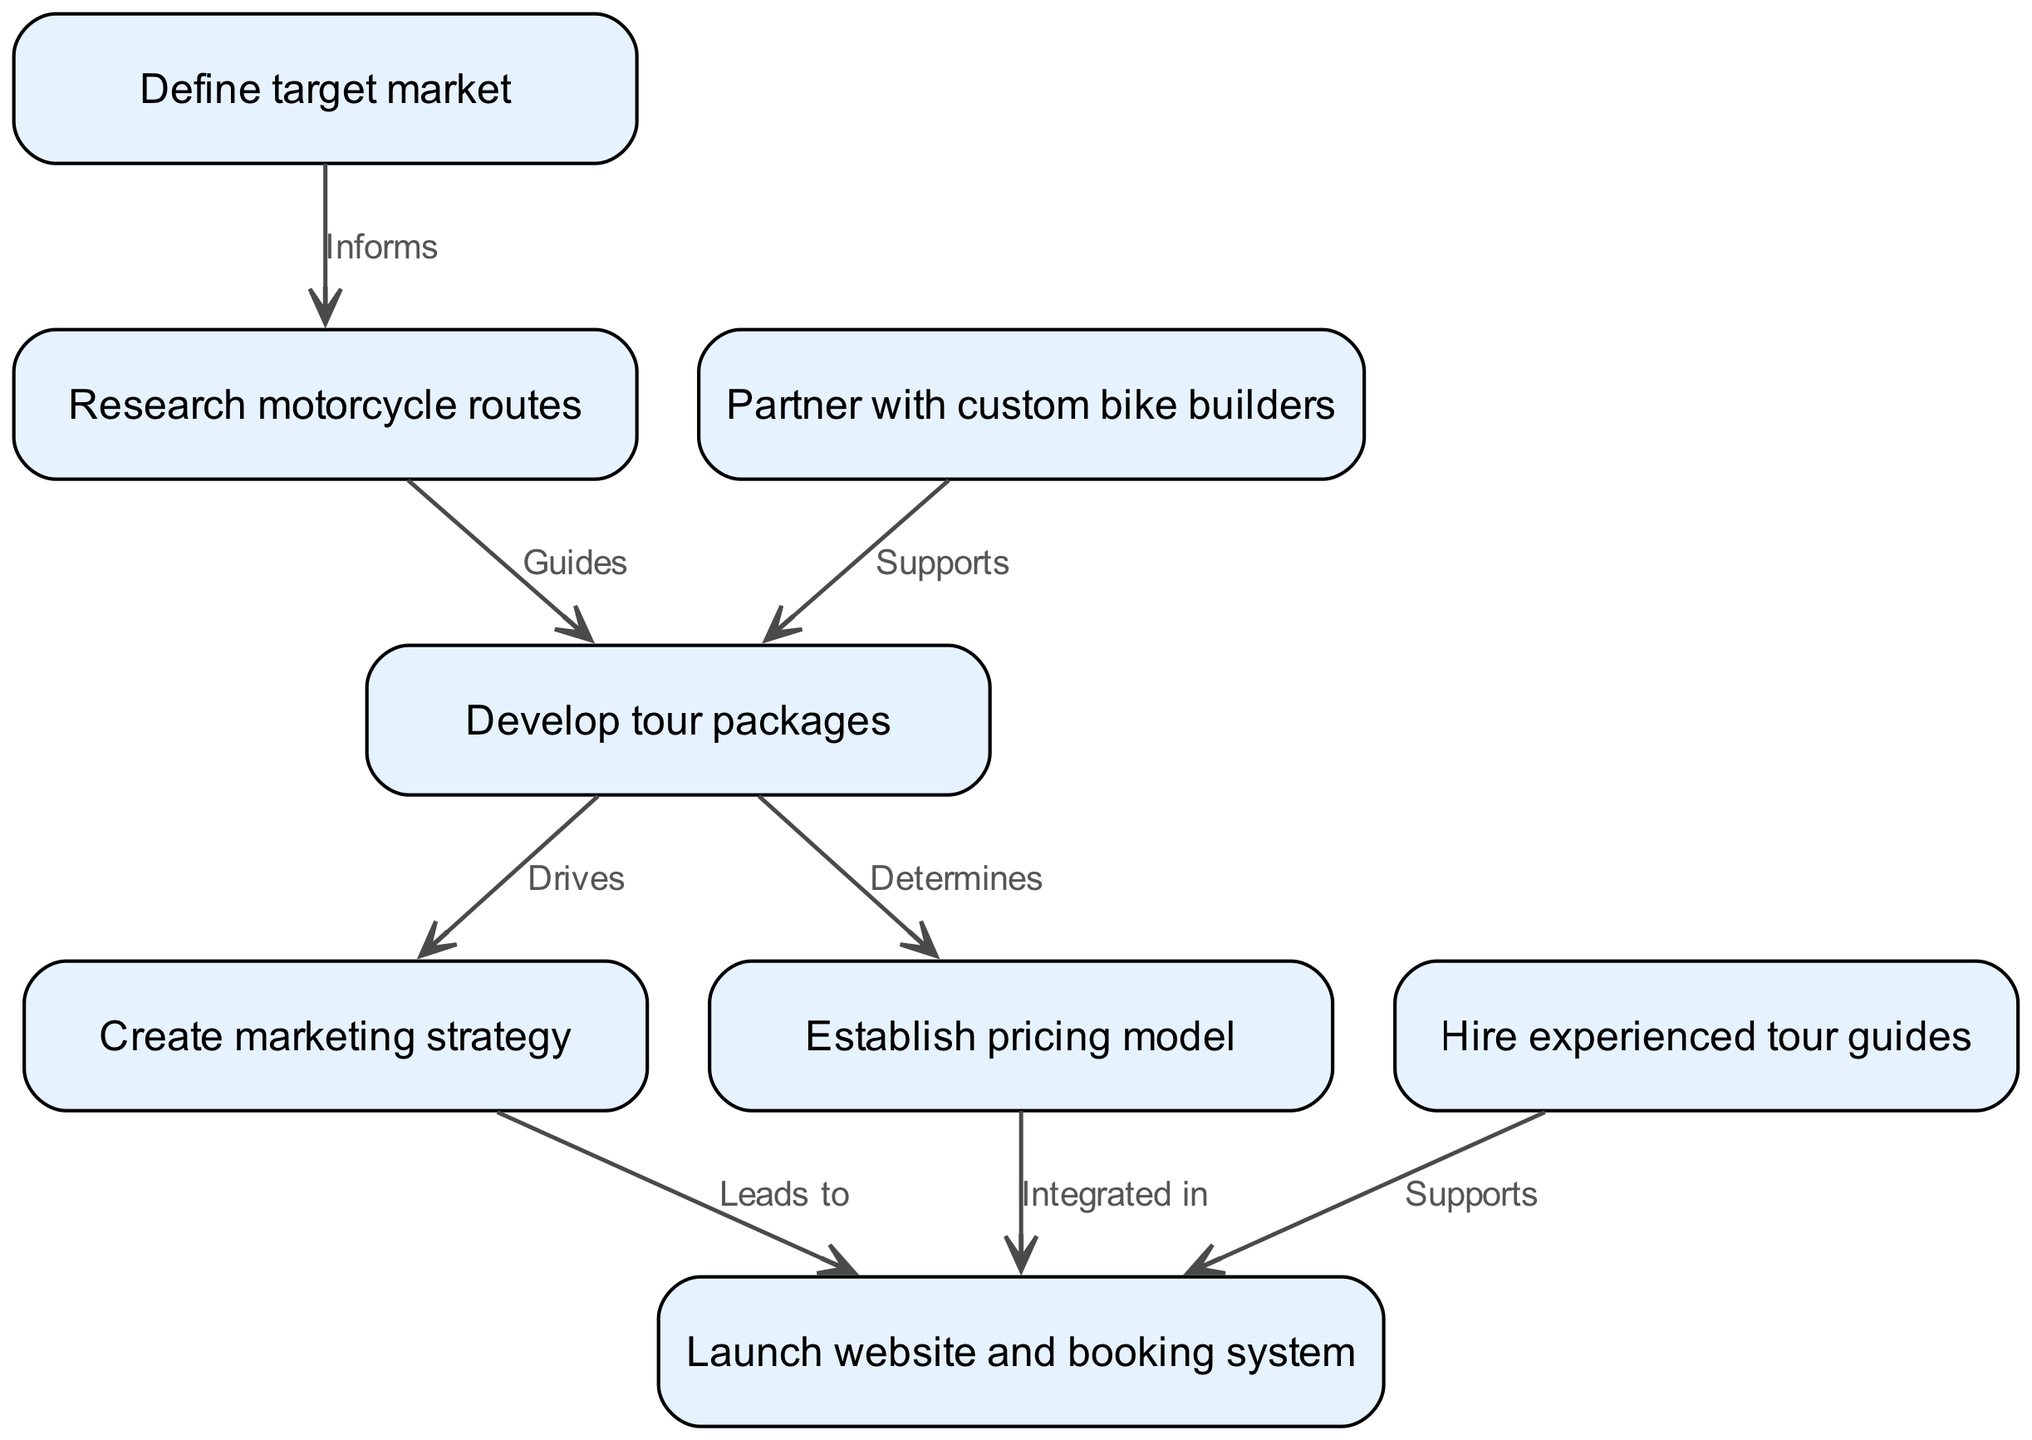What is the first step in the business plan flowchart? The first step in the flowchart is "Define target market," which is the initial node labeled '1'.
Answer: Define target market How many nodes are present in the diagram? The diagram includes a total of eight nodes that represent distinct steps or components in the business plan process.
Answer: 8 What does the "Research motorcycle routes" node inform? The "Research motorcycle routes" node is informed by the "Define target market" node, as shown by the directed edge between nodes 1 and 2.
Answer: Informs Which node supports the development of tour packages? The node "Partner with custom bike builders" supports the "Develop tour packages" node, indicated by the directed edge from node 3 to node 4.
Answer: Supports What drives the creation of the marketing strategy? The creation of the marketing strategy is driven by the "Develop tour packages" node, as indicated by the direct relationship between nodes 4 and 5 in the flowchart.
Answer: Drives Explain how established pricing relates to the website and booking system. The "Establish pricing model" node integrates with the "Launch website and booking system" node, meaning that pricing is a crucial part of the website's functionality, influencing how the service is presented and booked.
Answer: Integrated in Which nodes connect to "Launch website and booking system"? The nodes connecting to "Launch website and booking system" are "Create marketing strategy," "Establish pricing model," and "Hire experienced tour guides." Each node has a directed edge pointing to node 8, indicating their support for the website's launch.
Answer: 3 How many edges are there in the diagram? The diagram contains seven edges that represent the relationships between nodes. Each edge illustrates how one step influences or contributes to another in the business plan flow.
Answer: 7 What does the "Develop tour packages" node determine? The "Develop tour packages" node determines the "Establish pricing model," as indicated by the directed edge that shows how the specifics of package development impact pricing.
Answer: Determines 